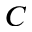Convert formula to latex. <formula><loc_0><loc_0><loc_500><loc_500>C</formula> 